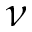Convert formula to latex. <formula><loc_0><loc_0><loc_500><loc_500>\nu</formula> 